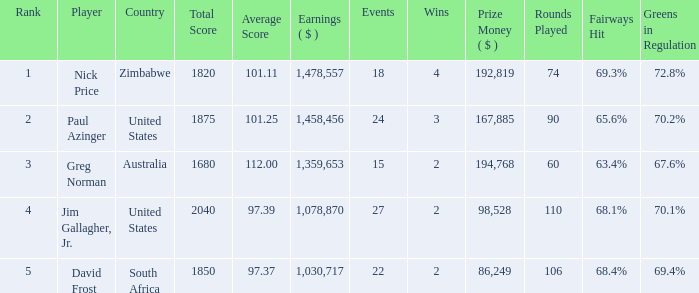How many events are in South Africa? 22.0. 